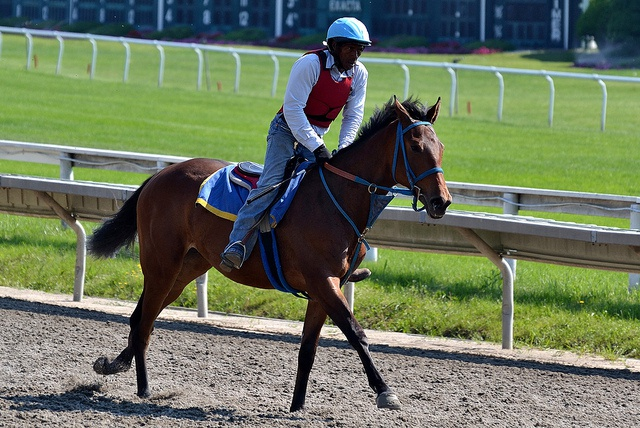Describe the objects in this image and their specific colors. I can see horse in navy, black, gray, and darkgray tones and people in navy, black, and gray tones in this image. 